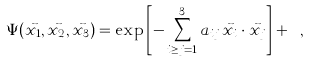Convert formula to latex. <formula><loc_0><loc_0><loc_500><loc_500>\Psi ( \vec { x _ { 1 } } , \vec { x _ { 2 } } , \vec { x _ { 3 } } ) = \exp \left [ - \sum _ { i \geq j = 1 } ^ { 3 } a _ { i j } \, \vec { x } _ { i } \cdot \vec { x } _ { j } \right ] + \cdots ,</formula> 